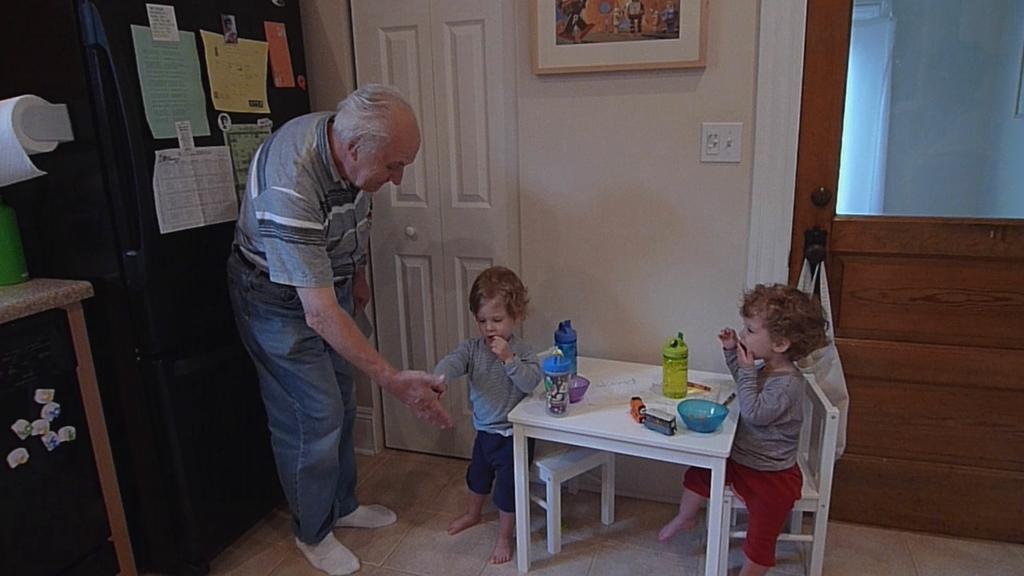What type of structure can be seen in the image? There is a wall in the image. Is there an entrance visible in the image? Yes, there is a door in the image. Who is present in the image? There is a man standing in the image. What furniture is in the image? There is a table in the image. What is on the table? There is a bowl and bottles on the table. What is located on the left side of the table? There is an almara on the left side of the table. What type of wrench is the man using in the image? There is no wrench present in the image. What level of experience does the man have in the image? The image does not provide information about the man's experience level, so it cannot be determined. 